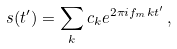Convert formula to latex. <formula><loc_0><loc_0><loc_500><loc_500>s ( t ^ { \prime } ) = \sum _ { k } c _ { k } e ^ { 2 \pi i f _ { m } k t ^ { \prime } } \, ,</formula> 